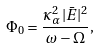<formula> <loc_0><loc_0><loc_500><loc_500>\Phi _ { 0 } = \frac { \kappa _ { \alpha } ^ { 2 } | \bar { E } | ^ { 2 } } { \omega - \Omega } ,</formula> 